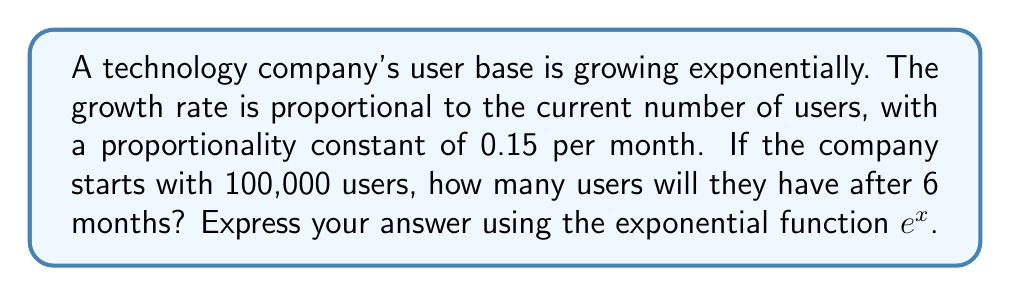Give your solution to this math problem. Let's approach this step-by-step:

1) First, we need to set up our differential equation. Let $U(t)$ be the number of users at time $t$ (in months). The growth rate is proportional to the current number of users, so we can write:

   $$\frac{dU}{dt} = kU$$

   where $k$ is the proportionality constant, given as 0.15 per month.

2) This is a separable first-order differential equation. We can solve it as follows:

   $$\frac{dU}{U} = k dt$$

3) Integrating both sides:

   $$\int \frac{dU}{U} = \int k dt$$
   $$\ln|U| = kt + C$$

4) Taking the exponential of both sides:

   $$U = e^{kt + C} = e^C \cdot e^{kt}$$

5) Let $A = e^C$. This is our initial condition. We're told that $U(0) = 100,000$, so:

   $$100,000 = A \cdot e^{k \cdot 0} = A$$

6) Therefore, our solution is:

   $$U(t) = 100,000 \cdot e^{0.15t}$$

7) To find the number of users after 6 months, we plug in $t = 6$:

   $$U(6) = 100,000 \cdot e^{0.15 \cdot 6} = 100,000 \cdot e^{0.9}$$

8) We can evaluate this using a calculator or leave it in this form.
Answer: $100,000 \cdot e^{0.9}$ users (approximately 245,960 users) 